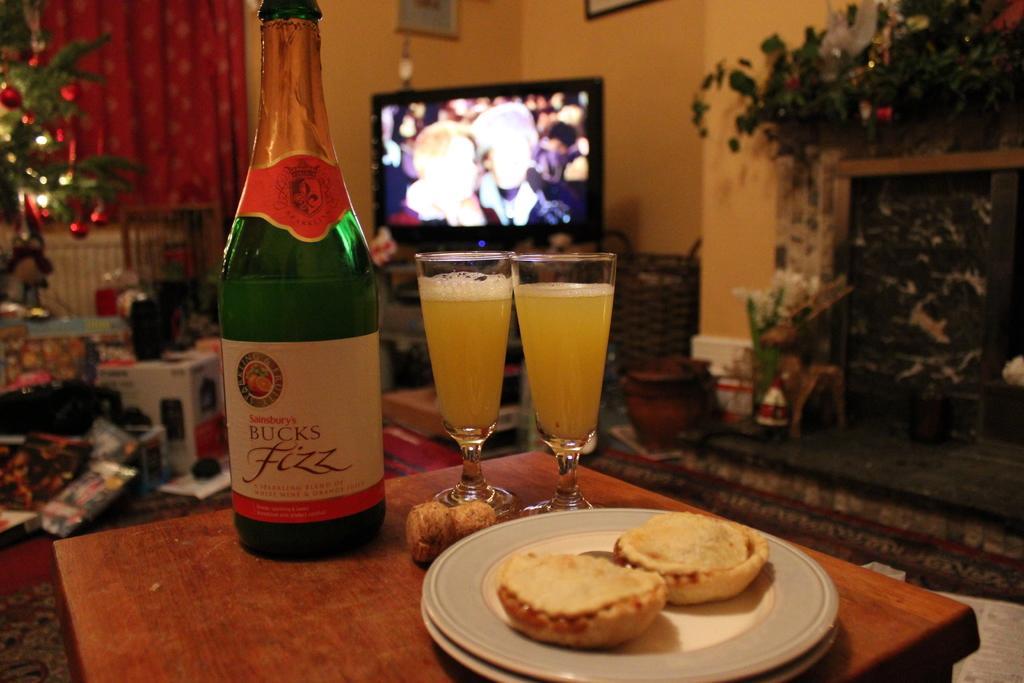Describe this image in one or two sentences. Image is clicked in a room. There is a Christmas tree on the left side and there are normal plants on the right side. There is a TV in the middle. On the stool which is in the front, there is a bottle, two glasses, plate and eatables. There is boxes, there are boxes on the left side and there is also a curtain on the left side. There are photo frames on the top. 